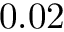<formula> <loc_0><loc_0><loc_500><loc_500>0 . 0 2</formula> 